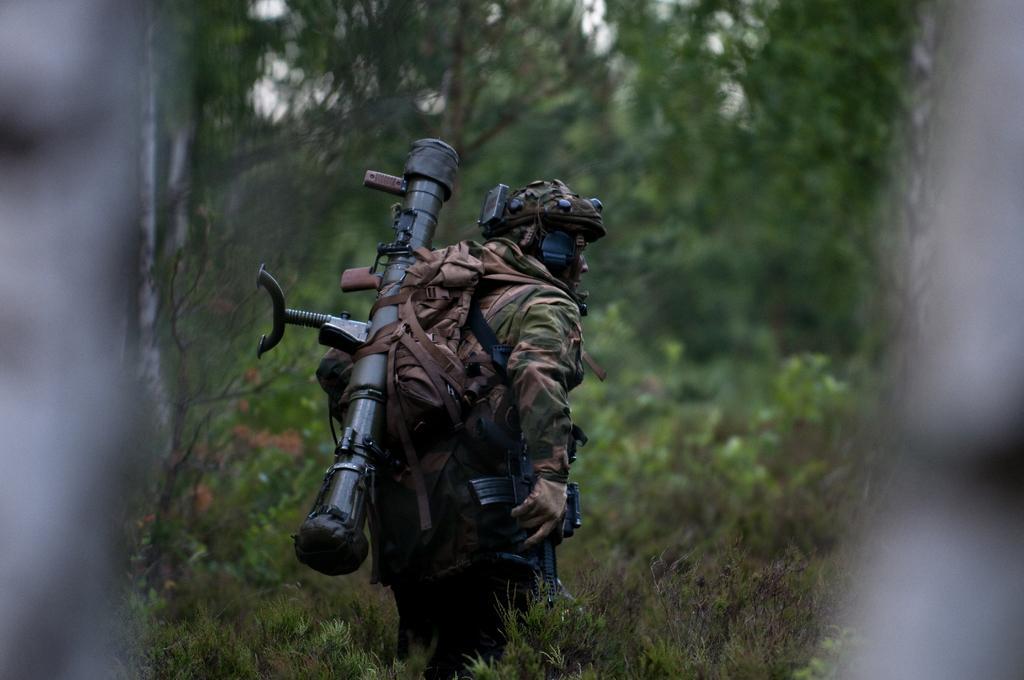Could you give a brief overview of what you see in this image? Here in this picture we can see a man wearing a military dress with helmet and carrying a bag and rocket launcher behind him, standing on the ground, which is fully covered with plants and grass and we can also see trees in the front in blurry manner. 